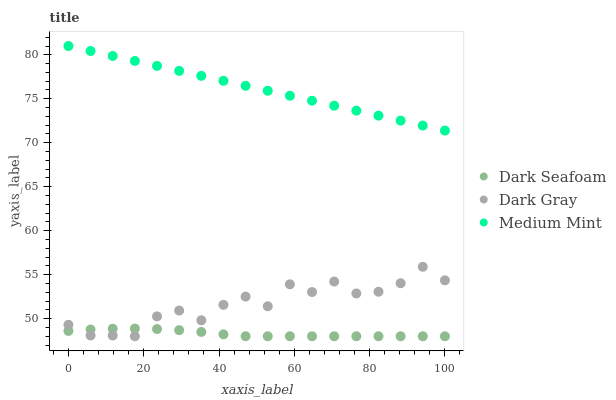Does Dark Seafoam have the minimum area under the curve?
Answer yes or no. Yes. Does Medium Mint have the maximum area under the curve?
Answer yes or no. Yes. Does Medium Mint have the minimum area under the curve?
Answer yes or no. No. Does Dark Seafoam have the maximum area under the curve?
Answer yes or no. No. Is Medium Mint the smoothest?
Answer yes or no. Yes. Is Dark Gray the roughest?
Answer yes or no. Yes. Is Dark Seafoam the smoothest?
Answer yes or no. No. Is Dark Seafoam the roughest?
Answer yes or no. No. Does Dark Gray have the lowest value?
Answer yes or no. Yes. Does Medium Mint have the lowest value?
Answer yes or no. No. Does Medium Mint have the highest value?
Answer yes or no. Yes. Does Dark Seafoam have the highest value?
Answer yes or no. No. Is Dark Seafoam less than Medium Mint?
Answer yes or no. Yes. Is Medium Mint greater than Dark Seafoam?
Answer yes or no. Yes. Does Dark Gray intersect Dark Seafoam?
Answer yes or no. Yes. Is Dark Gray less than Dark Seafoam?
Answer yes or no. No. Is Dark Gray greater than Dark Seafoam?
Answer yes or no. No. Does Dark Seafoam intersect Medium Mint?
Answer yes or no. No. 